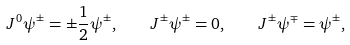Convert formula to latex. <formula><loc_0><loc_0><loc_500><loc_500>J ^ { 0 } \psi ^ { \pm } = \pm \frac { 1 } { 2 } \psi ^ { \pm } , \quad J ^ { \pm } \psi ^ { \pm } = 0 , \quad J ^ { \pm } \psi ^ { \mp } = \psi ^ { \pm } ,</formula> 